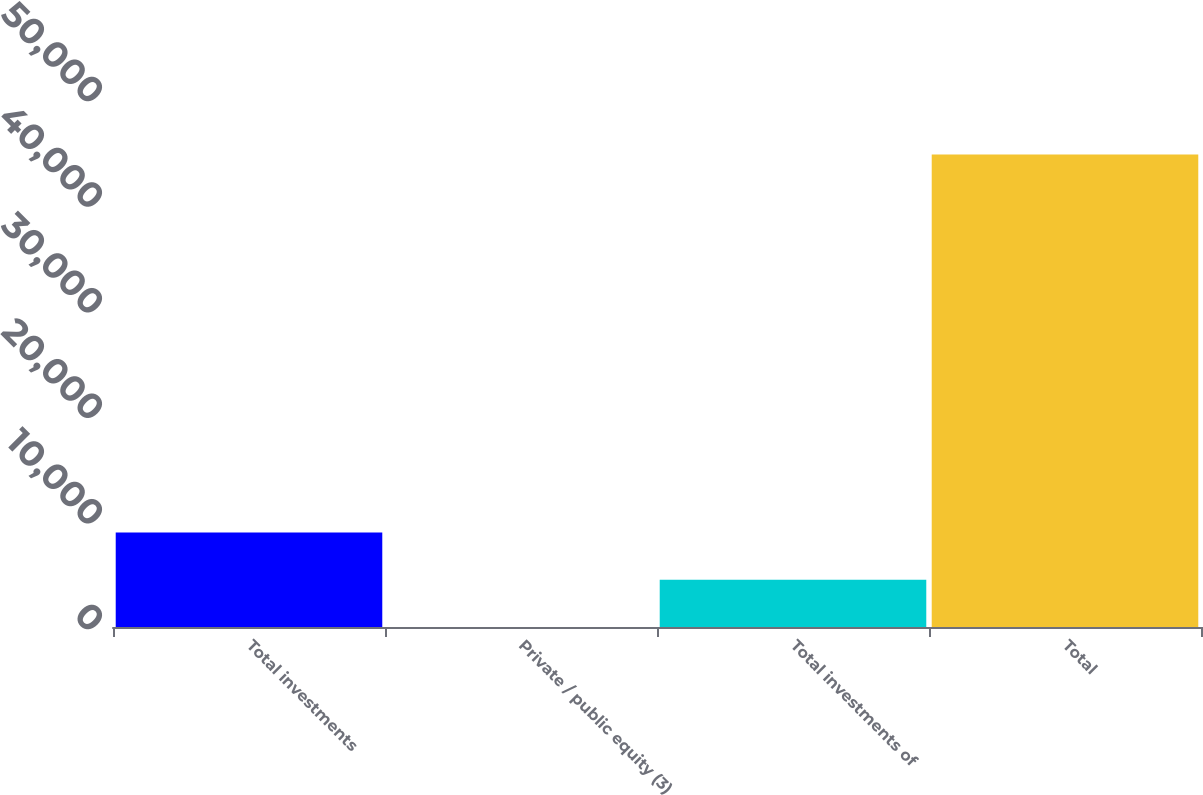Convert chart. <chart><loc_0><loc_0><loc_500><loc_500><bar_chart><fcel>Total investments<fcel>Private / public equity (3)<fcel>Total investments of<fcel>Total<nl><fcel>8948.8<fcel>2<fcel>4475.4<fcel>44736<nl></chart> 